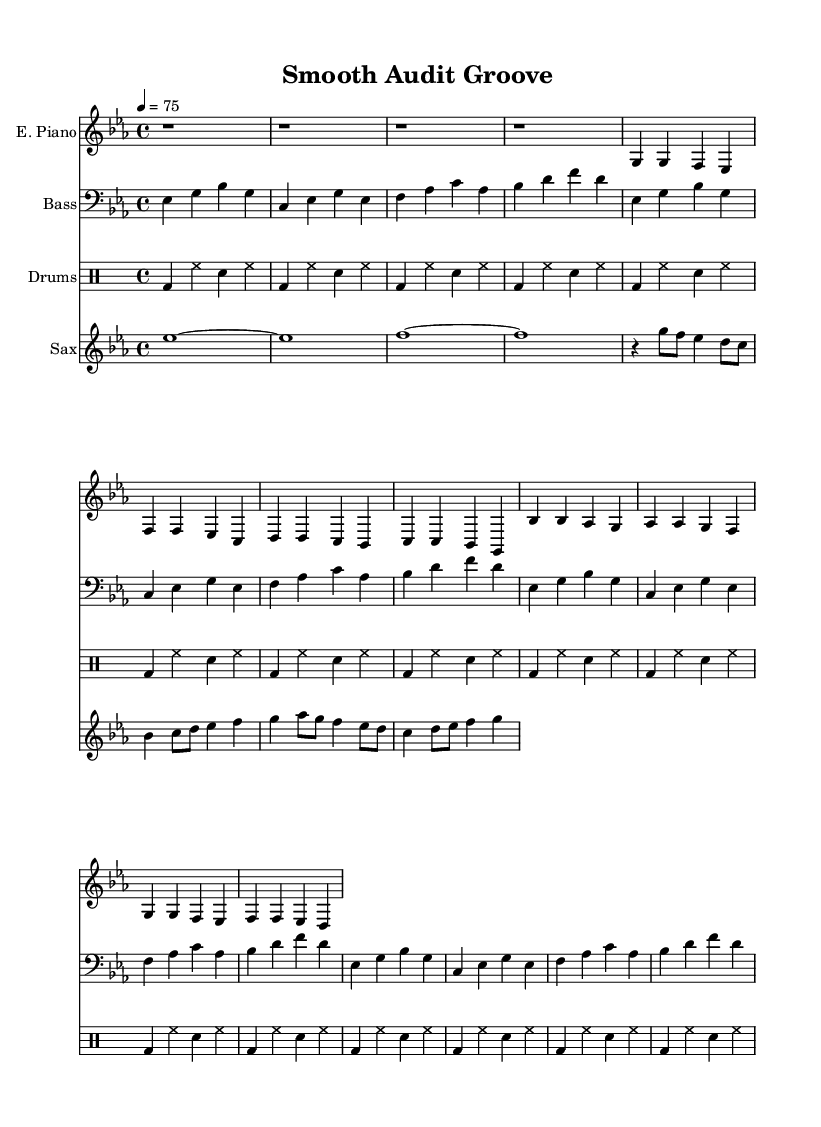What is the key signature of this music? The key signature is E flat major, which has three flats: B flat, E flat, and A flat. This is indicated at the beginning of the staff after the clef sign.
Answer: E flat major What is the time signature of this music? The time signature is 4/4, which is indicated at the beginning of the score. This means there are four beats in each measure, and each quarter note gets one beat.
Answer: 4/4 What is the tempo marking of this music? The tempo marking is "4 = 75," indicating a moderate pace at which the quarter note is set to 75 beats per minute. This is also mentioned at the beginning of the score.
Answer: 75 How many bars are in the intro of the electric piano part? The intro section consists of four measures, which are indicated by the four rest symbols (r1) that occupy the first four bars of the electric piano part.
Answer: 4 What is the instrument used for the melody in the chorus? The saxophone is used for the melody in the chorus, as seen in the separate staff labeled "Sax," which contains the melodic fills during the chorus section.
Answer: Saxophone How does the bass guitar part relate to the electric piano? The bass guitar part complements the electric piano by providing a harmonic foundation. Both parts are played in the same 4/4 time signature and are written in their respective staves aligned horizontally, showing their simultaneous performance.
Answer: Complementary What type of rhythm is used in the drum part? The drum part features a basic consistent rhythm primarily composed of bass drum, hi-hat, and snare hits, repeating every measure, providing a steady groove appropriate for the smooth soul genre.
Answer: Consistent 